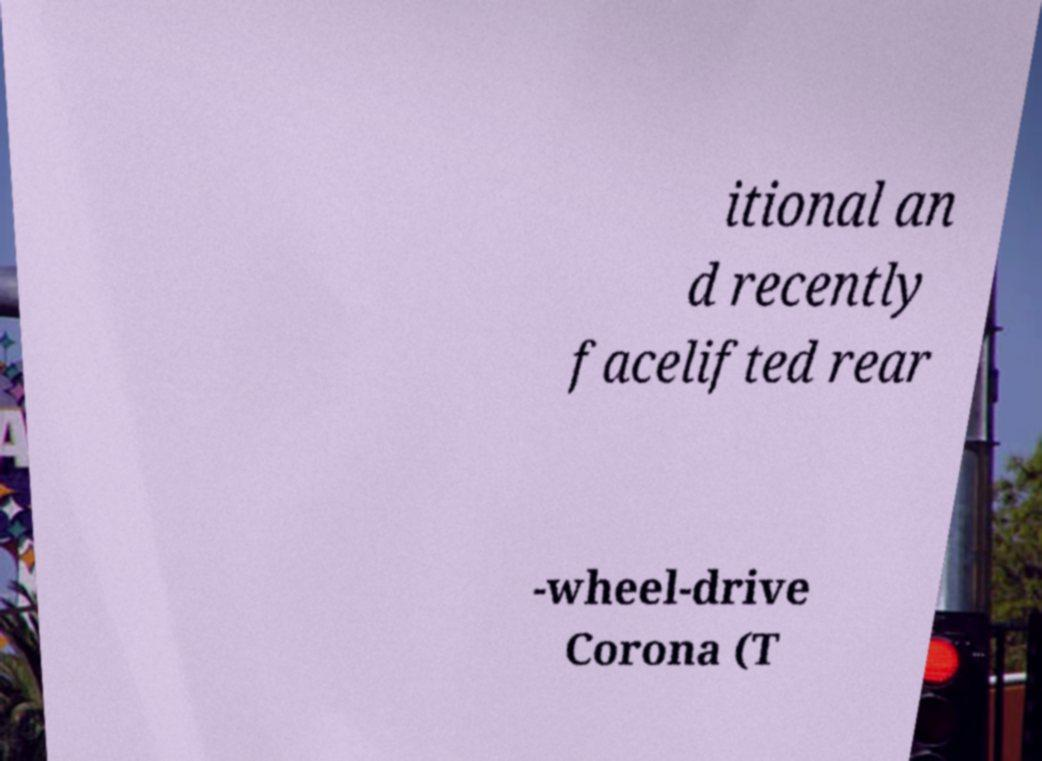Could you assist in decoding the text presented in this image and type it out clearly? itional an d recently facelifted rear -wheel-drive Corona (T 